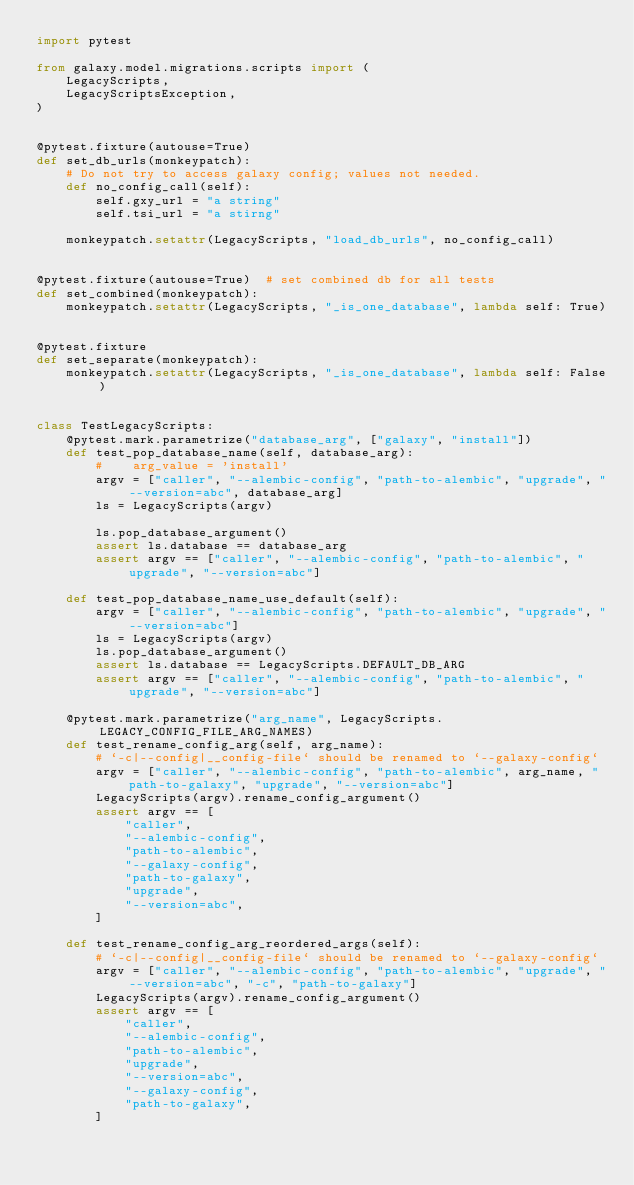<code> <loc_0><loc_0><loc_500><loc_500><_Python_>import pytest

from galaxy.model.migrations.scripts import (
    LegacyScripts,
    LegacyScriptsException,
)


@pytest.fixture(autouse=True)
def set_db_urls(monkeypatch):
    # Do not try to access galaxy config; values not needed.
    def no_config_call(self):
        self.gxy_url = "a string"
        self.tsi_url = "a stirng"

    monkeypatch.setattr(LegacyScripts, "load_db_urls", no_config_call)


@pytest.fixture(autouse=True)  # set combined db for all tests
def set_combined(monkeypatch):
    monkeypatch.setattr(LegacyScripts, "_is_one_database", lambda self: True)


@pytest.fixture
def set_separate(monkeypatch):
    monkeypatch.setattr(LegacyScripts, "_is_one_database", lambda self: False)


class TestLegacyScripts:
    @pytest.mark.parametrize("database_arg", ["galaxy", "install"])
    def test_pop_database_name(self, database_arg):
        #    arg_value = 'install'
        argv = ["caller", "--alembic-config", "path-to-alembic", "upgrade", "--version=abc", database_arg]
        ls = LegacyScripts(argv)

        ls.pop_database_argument()
        assert ls.database == database_arg
        assert argv == ["caller", "--alembic-config", "path-to-alembic", "upgrade", "--version=abc"]

    def test_pop_database_name_use_default(self):
        argv = ["caller", "--alembic-config", "path-to-alembic", "upgrade", "--version=abc"]
        ls = LegacyScripts(argv)
        ls.pop_database_argument()
        assert ls.database == LegacyScripts.DEFAULT_DB_ARG
        assert argv == ["caller", "--alembic-config", "path-to-alembic", "upgrade", "--version=abc"]

    @pytest.mark.parametrize("arg_name", LegacyScripts.LEGACY_CONFIG_FILE_ARG_NAMES)
    def test_rename_config_arg(self, arg_name):
        # `-c|--config|__config-file` should be renamed to `--galaxy-config`
        argv = ["caller", "--alembic-config", "path-to-alembic", arg_name, "path-to-galaxy", "upgrade", "--version=abc"]
        LegacyScripts(argv).rename_config_argument()
        assert argv == [
            "caller",
            "--alembic-config",
            "path-to-alembic",
            "--galaxy-config",
            "path-to-galaxy",
            "upgrade",
            "--version=abc",
        ]

    def test_rename_config_arg_reordered_args(self):
        # `-c|--config|__config-file` should be renamed to `--galaxy-config`
        argv = ["caller", "--alembic-config", "path-to-alembic", "upgrade", "--version=abc", "-c", "path-to-galaxy"]
        LegacyScripts(argv).rename_config_argument()
        assert argv == [
            "caller",
            "--alembic-config",
            "path-to-alembic",
            "upgrade",
            "--version=abc",
            "--galaxy-config",
            "path-to-galaxy",
        ]
</code> 